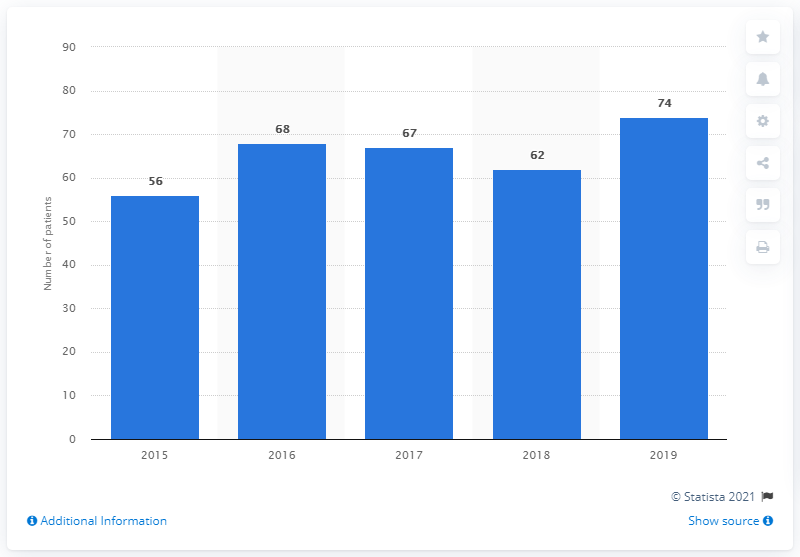Identify some key points in this picture. There were 74 patients on the waiting list for a kidney transplant in Cyprus in 2019. 